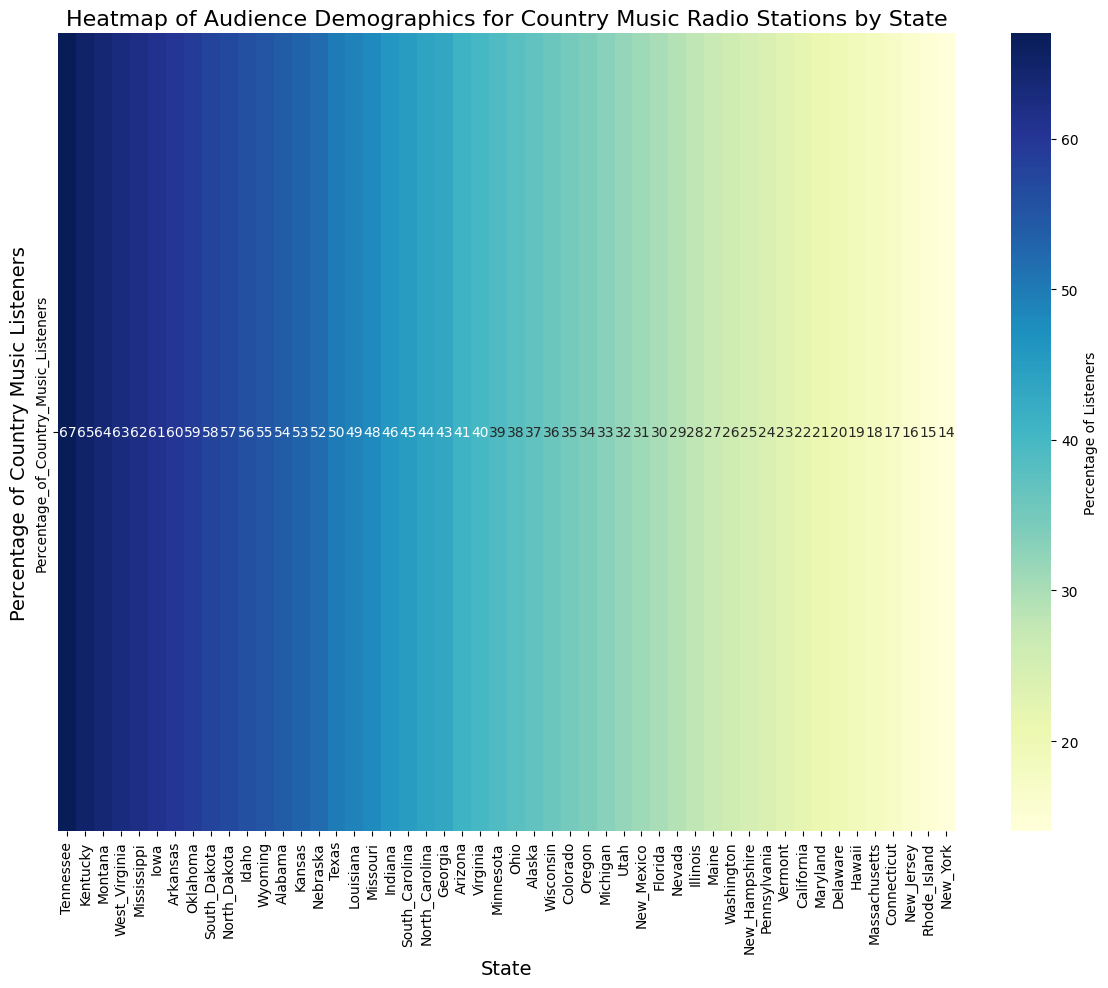Which state has the highest percentage of country music listeners? By looking at the color intensity on the heatmap, Tennessee has the darkest shade, indicating the highest percentage. This state's annotation shows 67%.
Answer: Tennessee Which state has the lowest percentage of country music listeners? The lightest color shade on the heatmap represents the lowest percentage, which is in New York, with an annotation of 14%.
Answer: New York What is the difference in the percentage of country music listeners between Texas and California? The percentage of country music listeners in Texas is 50%, and in California, it is 22%. The difference between them is 50 - 22 = 28%.
Answer: 28% Which states have a percentage of country music listeners greater than 60%? By checking the percentages, the states with more than 60% listeners are Kentucky (65%), Mississippi (62%), Iowa (61%), and Tennessee (67%).
Answer: Kentucky, Mississippi, Iowa, Tennessee What is the median percentage of country music listeners across all states listed? To find the median, the percentages must be ordered from smallest to largest and the middle value identified. The sorted percentages show that the middle values (since there are 51 states) are 34% and 35%. The median is the average of these two: (34+35)/2 = 34.5%.
Answer: 34.5% Which state has a higher percentage of country music listeners, Florida or Illinois, and by how much? Florida's percentage is 30% and Illinois' is 28%. The difference is 30 - 28 = 2%. Therefore, Florida has a higher percentage by 2%.
Answer: Florida by 2% How many states have a percentage of country music listeners between 20% and 30%? From the heatmap, the states falling within this range are California (22%), Delaware (20%), Maryland (21%), Nevada (29%), Vermont (23%), and Washington (26%), which totals 6 states.
Answer: 6 states What is the color shade that represents the state with 45% of country music listeners? The shade for South Carolina, which has 45%, is a dark green tone representing the mid to high percentage range.
Answer: Dark green Which states have exactly 49% of their population listening to country music? Louisiana is the only state annotated with 49% in the heatmap.
Answer: Louisiana What is the average percentage of country music listeners for the states having more than 50% listeners? The states are Alabama (54%), Arkansas (60%), Idaho (56%), Iowa (61%), Kentucky (65%), Mississippi (62%), Montana (64%), North Dakota (57%), Oklahoma (59%), South Dakota (58%), Tennessee (67%), Texas (50%), West Virginia (63%), and Wyoming (55%). Summing these gives 881. The number of states is 14. The average is 881/14 = 62.93%.
Answer: 62.93% 